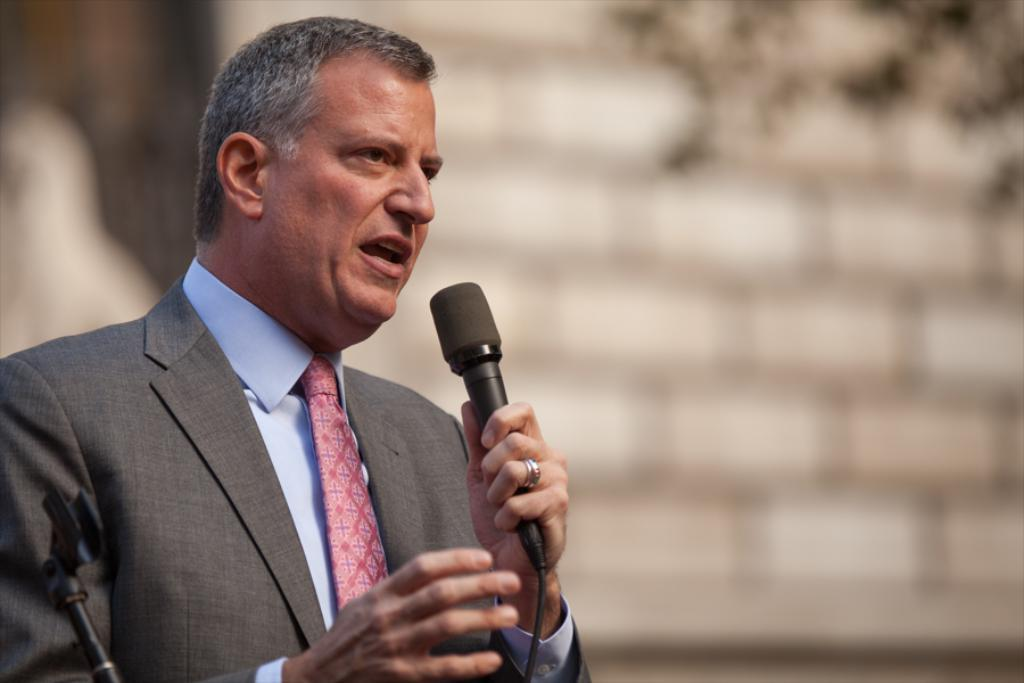Who is the main subject in the image? There is a man in the image. What is the man holding in his hand? The man is holding a microphone in his hand. How is the microphone being used? The microphone is being used for speaking. What type of glove is the man wearing while holding the microphone? The man is not wearing any gloves in the image. 